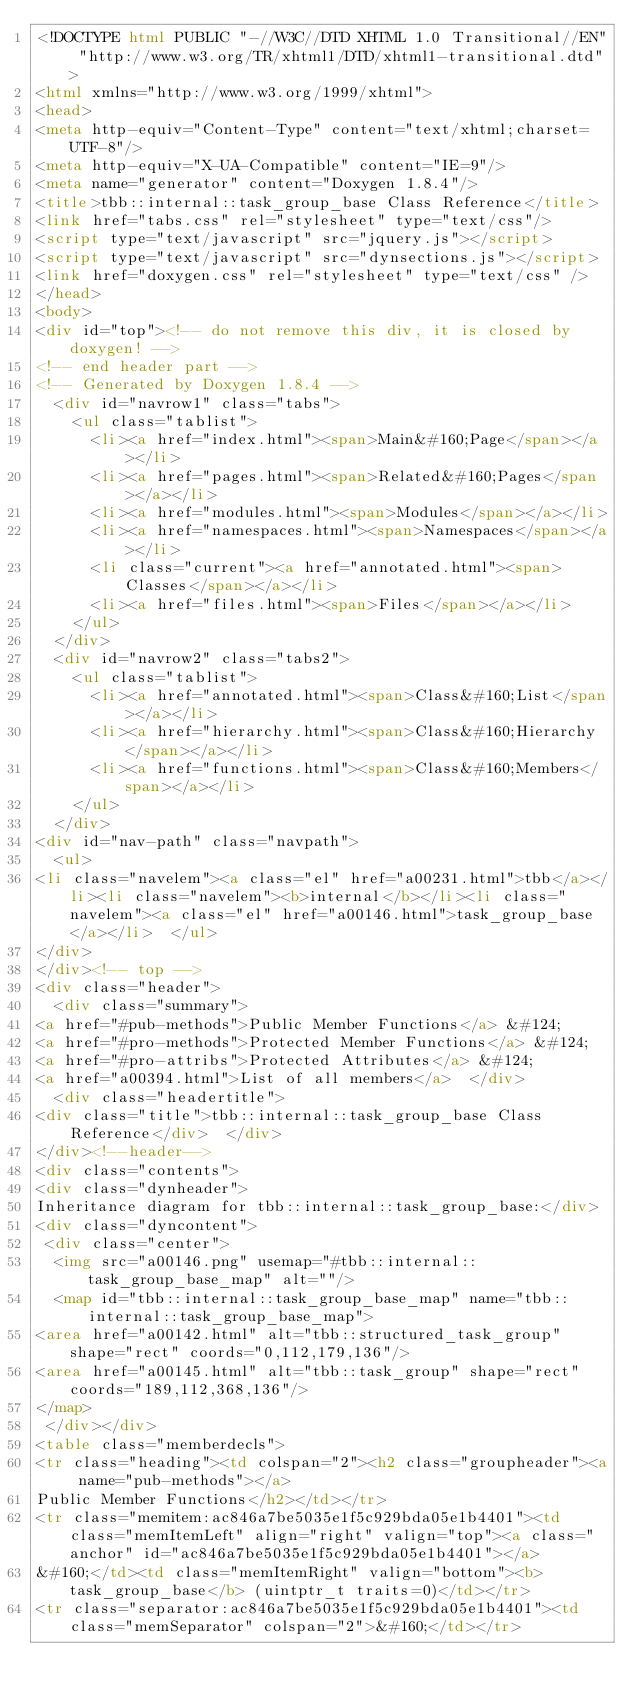<code> <loc_0><loc_0><loc_500><loc_500><_HTML_><!DOCTYPE html PUBLIC "-//W3C//DTD XHTML 1.0 Transitional//EN" "http://www.w3.org/TR/xhtml1/DTD/xhtml1-transitional.dtd">
<html xmlns="http://www.w3.org/1999/xhtml">
<head>
<meta http-equiv="Content-Type" content="text/xhtml;charset=UTF-8"/>
<meta http-equiv="X-UA-Compatible" content="IE=9"/>
<meta name="generator" content="Doxygen 1.8.4"/>
<title>tbb::internal::task_group_base Class Reference</title>
<link href="tabs.css" rel="stylesheet" type="text/css"/>
<script type="text/javascript" src="jquery.js"></script>
<script type="text/javascript" src="dynsections.js"></script>
<link href="doxygen.css" rel="stylesheet" type="text/css" />
</head>
<body>
<div id="top"><!-- do not remove this div, it is closed by doxygen! -->
<!-- end header part -->
<!-- Generated by Doxygen 1.8.4 -->
  <div id="navrow1" class="tabs">
    <ul class="tablist">
      <li><a href="index.html"><span>Main&#160;Page</span></a></li>
      <li><a href="pages.html"><span>Related&#160;Pages</span></a></li>
      <li><a href="modules.html"><span>Modules</span></a></li>
      <li><a href="namespaces.html"><span>Namespaces</span></a></li>
      <li class="current"><a href="annotated.html"><span>Classes</span></a></li>
      <li><a href="files.html"><span>Files</span></a></li>
    </ul>
  </div>
  <div id="navrow2" class="tabs2">
    <ul class="tablist">
      <li><a href="annotated.html"><span>Class&#160;List</span></a></li>
      <li><a href="hierarchy.html"><span>Class&#160;Hierarchy</span></a></li>
      <li><a href="functions.html"><span>Class&#160;Members</span></a></li>
    </ul>
  </div>
<div id="nav-path" class="navpath">
  <ul>
<li class="navelem"><a class="el" href="a00231.html">tbb</a></li><li class="navelem"><b>internal</b></li><li class="navelem"><a class="el" href="a00146.html">task_group_base</a></li>  </ul>
</div>
</div><!-- top -->
<div class="header">
  <div class="summary">
<a href="#pub-methods">Public Member Functions</a> &#124;
<a href="#pro-methods">Protected Member Functions</a> &#124;
<a href="#pro-attribs">Protected Attributes</a> &#124;
<a href="a00394.html">List of all members</a>  </div>
  <div class="headertitle">
<div class="title">tbb::internal::task_group_base Class Reference</div>  </div>
</div><!--header-->
<div class="contents">
<div class="dynheader">
Inheritance diagram for tbb::internal::task_group_base:</div>
<div class="dyncontent">
 <div class="center">
  <img src="a00146.png" usemap="#tbb::internal::task_group_base_map" alt=""/>
  <map id="tbb::internal::task_group_base_map" name="tbb::internal::task_group_base_map">
<area href="a00142.html" alt="tbb::structured_task_group" shape="rect" coords="0,112,179,136"/>
<area href="a00145.html" alt="tbb::task_group" shape="rect" coords="189,112,368,136"/>
</map>
 </div></div>
<table class="memberdecls">
<tr class="heading"><td colspan="2"><h2 class="groupheader"><a name="pub-methods"></a>
Public Member Functions</h2></td></tr>
<tr class="memitem:ac846a7be5035e1f5c929bda05e1b4401"><td class="memItemLeft" align="right" valign="top"><a class="anchor" id="ac846a7be5035e1f5c929bda05e1b4401"></a>
&#160;</td><td class="memItemRight" valign="bottom"><b>task_group_base</b> (uintptr_t traits=0)</td></tr>
<tr class="separator:ac846a7be5035e1f5c929bda05e1b4401"><td class="memSeparator" colspan="2">&#160;</td></tr></code> 